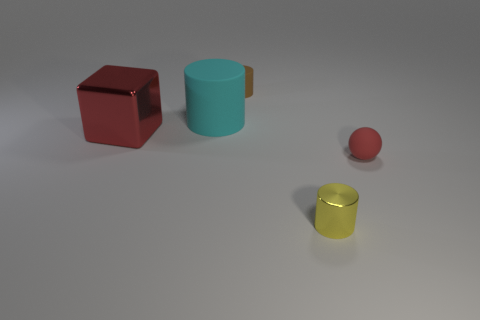What material is the small object left of the small cylinder in front of the brown cylinder?
Ensure brevity in your answer.  Rubber. The tiny metal object has what color?
Provide a short and direct response. Yellow. There is a metallic thing to the right of the small matte cylinder; is its color the same as the metallic object on the left side of the tiny yellow object?
Give a very brief answer. No. What is the size of the brown thing that is the same shape as the yellow metallic thing?
Provide a succinct answer. Small. Are there any large objects of the same color as the big cylinder?
Ensure brevity in your answer.  No. What is the material of the tiny thing that is the same color as the metallic block?
Provide a succinct answer. Rubber. What number of spheres are the same color as the cube?
Keep it short and to the point. 1. What number of things are either rubber things that are behind the red cube or tiny purple shiny spheres?
Ensure brevity in your answer.  2. There is a large thing that is made of the same material as the small yellow thing; what color is it?
Give a very brief answer. Red. Is there a green rubber block that has the same size as the brown thing?
Offer a terse response. No. 